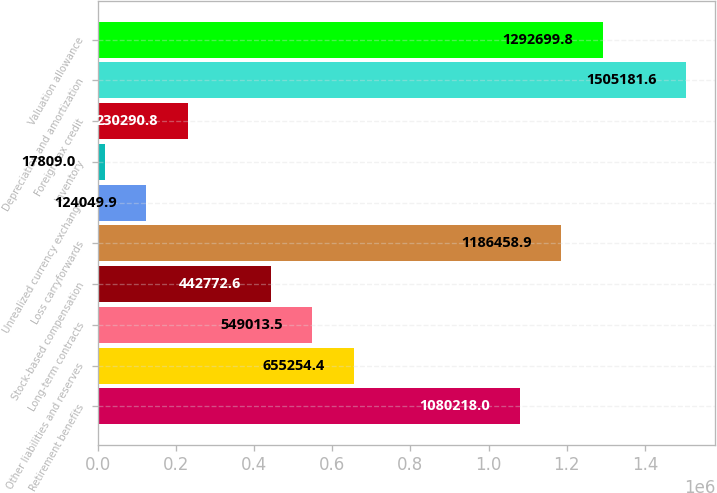Convert chart. <chart><loc_0><loc_0><loc_500><loc_500><bar_chart><fcel>Retirement benefits<fcel>Other liabilities and reserves<fcel>Long-term contracts<fcel>Stock-based compensation<fcel>Loss carryforwards<fcel>Unrealized currency exchange<fcel>Inventory<fcel>Foreign tax credit<fcel>Depreciation and amortization<fcel>Valuation allowance<nl><fcel>1.08022e+06<fcel>655254<fcel>549014<fcel>442773<fcel>1.18646e+06<fcel>124050<fcel>17809<fcel>230291<fcel>1.50518e+06<fcel>1.2927e+06<nl></chart> 